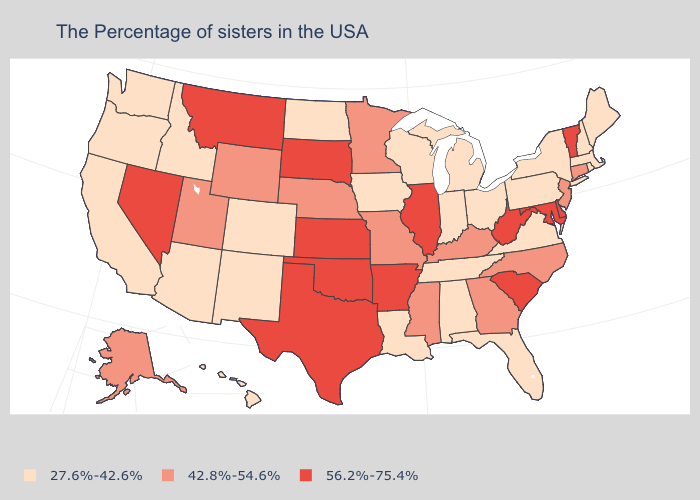What is the lowest value in the MidWest?
Be succinct. 27.6%-42.6%. Which states have the lowest value in the USA?
Short answer required. Maine, Massachusetts, Rhode Island, New Hampshire, New York, Pennsylvania, Virginia, Ohio, Florida, Michigan, Indiana, Alabama, Tennessee, Wisconsin, Louisiana, Iowa, North Dakota, Colorado, New Mexico, Arizona, Idaho, California, Washington, Oregon, Hawaii. Does New Jersey have a higher value than South Dakota?
Write a very short answer. No. Does the first symbol in the legend represent the smallest category?
Quick response, please. Yes. Name the states that have a value in the range 56.2%-75.4%?
Give a very brief answer. Vermont, Delaware, Maryland, South Carolina, West Virginia, Illinois, Arkansas, Kansas, Oklahoma, Texas, South Dakota, Montana, Nevada. What is the highest value in the USA?
Write a very short answer. 56.2%-75.4%. What is the value of Ohio?
Give a very brief answer. 27.6%-42.6%. Does Arizona have a higher value than Mississippi?
Quick response, please. No. How many symbols are there in the legend?
Keep it brief. 3. Among the states that border Delaware , does Maryland have the lowest value?
Give a very brief answer. No. What is the value of Missouri?
Answer briefly. 42.8%-54.6%. Which states hav the highest value in the West?
Quick response, please. Montana, Nevada. What is the highest value in states that border New Hampshire?
Write a very short answer. 56.2%-75.4%. Name the states that have a value in the range 42.8%-54.6%?
Keep it brief. Connecticut, New Jersey, North Carolina, Georgia, Kentucky, Mississippi, Missouri, Minnesota, Nebraska, Wyoming, Utah, Alaska. Does the first symbol in the legend represent the smallest category?
Concise answer only. Yes. 